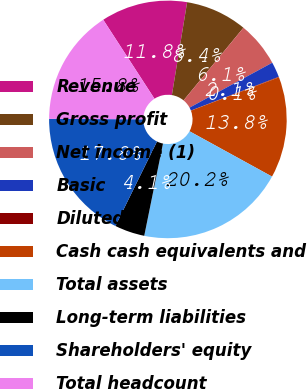<chart> <loc_0><loc_0><loc_500><loc_500><pie_chart><fcel>Revenue<fcel>Gross profit<fcel>Net income (1)<fcel>Basic<fcel>Diluted<fcel>Cash cash equivalents and<fcel>Total assets<fcel>Long-term liabilities<fcel>Shareholders' equity<fcel>Total headcount<nl><fcel>11.75%<fcel>8.38%<fcel>6.11%<fcel>2.08%<fcel>0.07%<fcel>13.76%<fcel>20.2%<fcel>4.09%<fcel>17.79%<fcel>15.77%<nl></chart> 